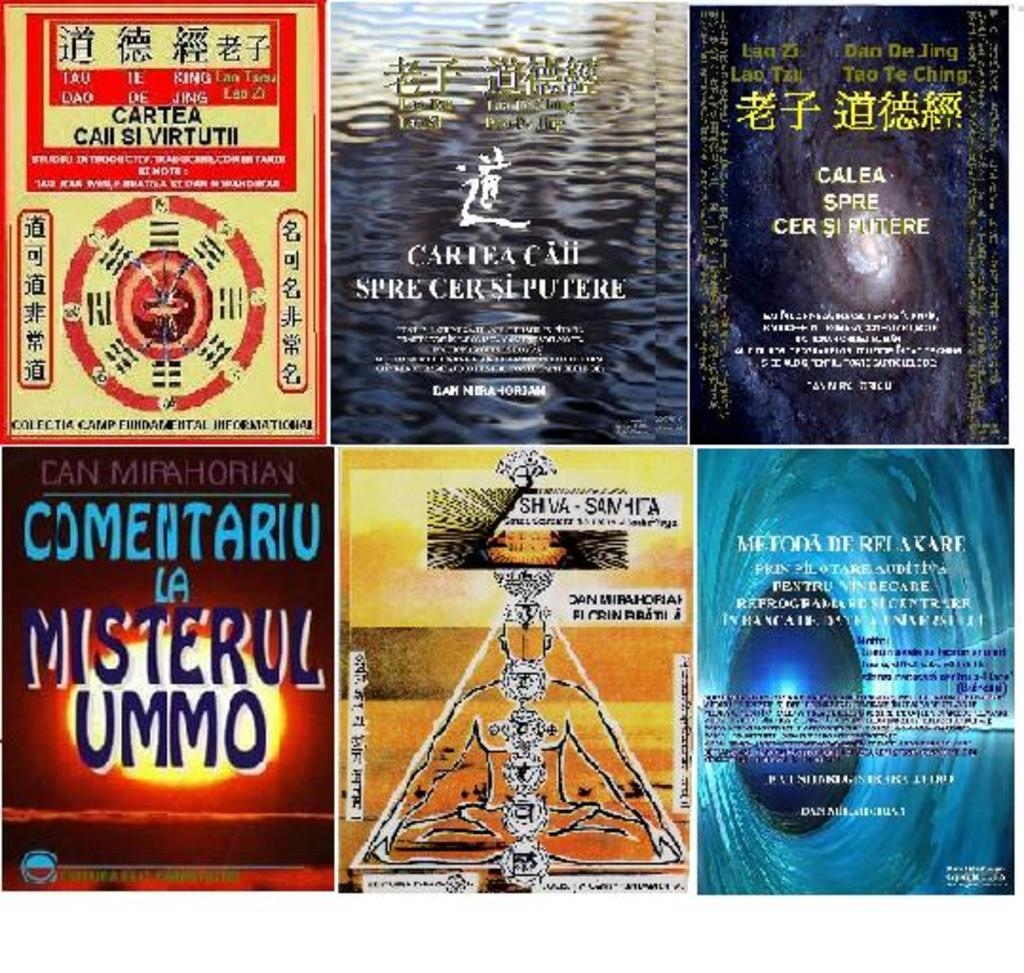What type of image is displayed with the six front covers of books? The image is a collage. How many front covers of books are visible in the collage? There are six front covers of books in the image. What type of cannon is depicted on one of the book covers in the image? There is no cannon depicted on any of the book covers in the image. How does the icicle affect the appearance of the book covers in the image? There is no icicle present in the image; it is a collage of book covers. 